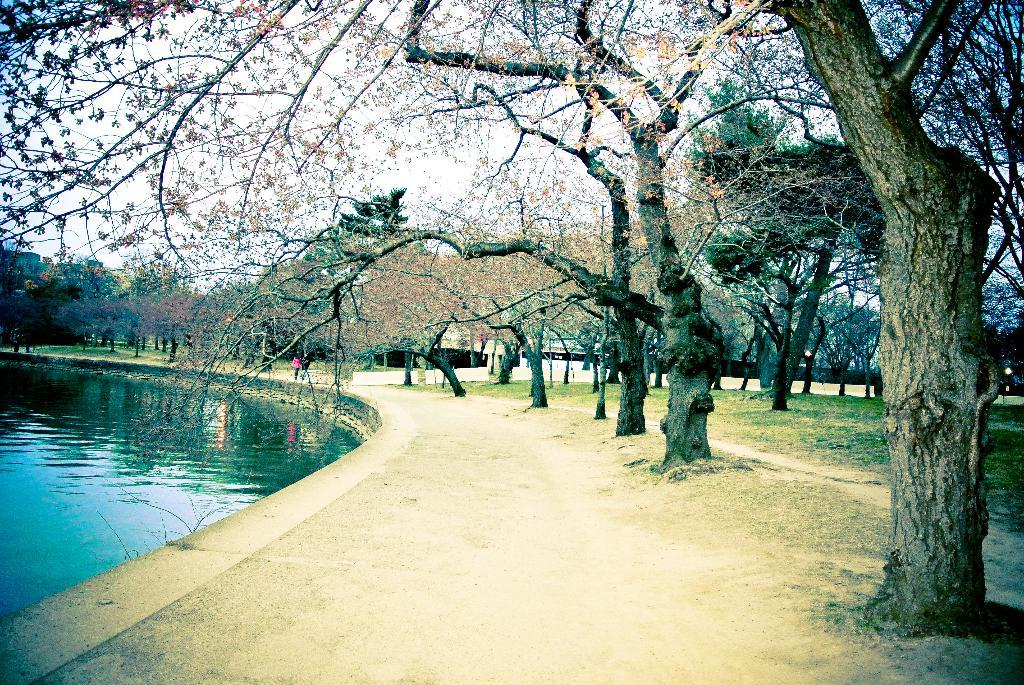What types of trees can be seen in the image? There are dried trees and green trees in the image. What else is visible in the image besides the trees? There is water visible in the image. Can you describe the person in the image? The person in the image is wearing a pink shirt and black pants. What is the color of the sky in the background of the image? The sky in the background of the image is white. How many baskets can be seen in the image? There are no baskets present in the image. What type of horses are depicted in the image? There are no horses present in the image. 